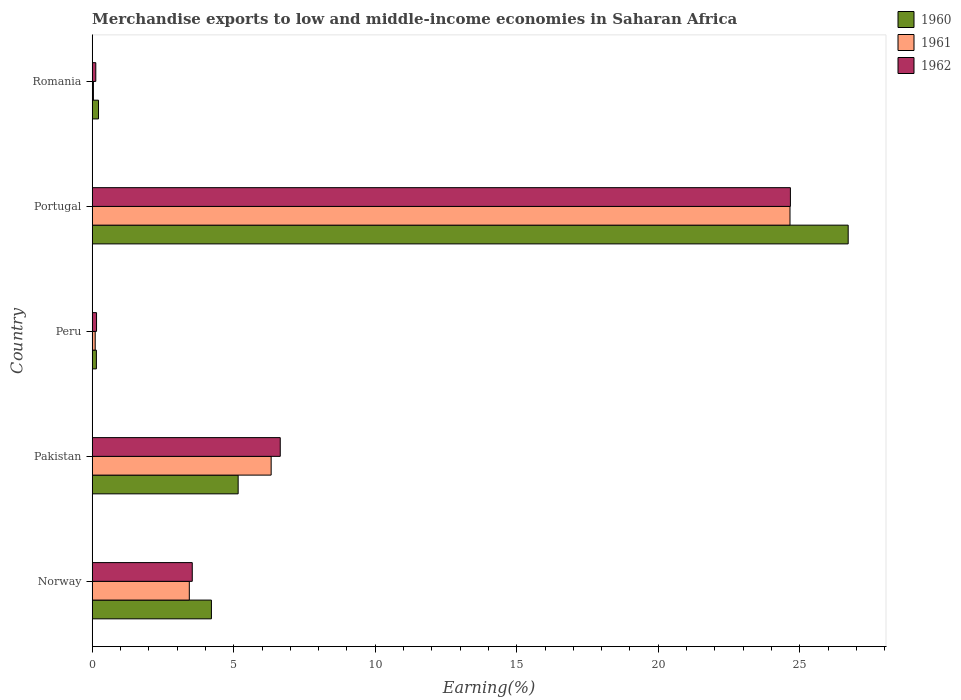How many different coloured bars are there?
Ensure brevity in your answer.  3. How many bars are there on the 3rd tick from the top?
Give a very brief answer. 3. How many bars are there on the 1st tick from the bottom?
Offer a very short reply. 3. What is the label of the 3rd group of bars from the top?
Provide a succinct answer. Peru. In how many cases, is the number of bars for a given country not equal to the number of legend labels?
Offer a terse response. 0. What is the percentage of amount earned from merchandise exports in 1960 in Portugal?
Provide a short and direct response. 26.71. Across all countries, what is the maximum percentage of amount earned from merchandise exports in 1960?
Keep it short and to the point. 26.71. Across all countries, what is the minimum percentage of amount earned from merchandise exports in 1960?
Offer a terse response. 0.15. In which country was the percentage of amount earned from merchandise exports in 1962 maximum?
Ensure brevity in your answer.  Portugal. In which country was the percentage of amount earned from merchandise exports in 1961 minimum?
Your answer should be very brief. Romania. What is the total percentage of amount earned from merchandise exports in 1961 in the graph?
Offer a terse response. 34.55. What is the difference between the percentage of amount earned from merchandise exports in 1960 in Peru and that in Romania?
Your response must be concise. -0.07. What is the difference between the percentage of amount earned from merchandise exports in 1961 in Peru and the percentage of amount earned from merchandise exports in 1960 in Portugal?
Your answer should be very brief. -26.6. What is the average percentage of amount earned from merchandise exports in 1961 per country?
Ensure brevity in your answer.  6.91. What is the difference between the percentage of amount earned from merchandise exports in 1961 and percentage of amount earned from merchandise exports in 1960 in Pakistan?
Your answer should be compact. 1.17. In how many countries, is the percentage of amount earned from merchandise exports in 1960 greater than 1 %?
Provide a succinct answer. 3. What is the ratio of the percentage of amount earned from merchandise exports in 1960 in Peru to that in Portugal?
Your answer should be compact. 0.01. Is the percentage of amount earned from merchandise exports in 1962 in Pakistan less than that in Romania?
Your response must be concise. No. Is the difference between the percentage of amount earned from merchandise exports in 1961 in Pakistan and Peru greater than the difference between the percentage of amount earned from merchandise exports in 1960 in Pakistan and Peru?
Your answer should be very brief. Yes. What is the difference between the highest and the second highest percentage of amount earned from merchandise exports in 1960?
Provide a short and direct response. 21.55. What is the difference between the highest and the lowest percentage of amount earned from merchandise exports in 1960?
Your answer should be compact. 26.56. Is the sum of the percentage of amount earned from merchandise exports in 1961 in Pakistan and Romania greater than the maximum percentage of amount earned from merchandise exports in 1962 across all countries?
Your answer should be compact. No. What does the 2nd bar from the bottom in Portugal represents?
Provide a succinct answer. 1961. What is the difference between two consecutive major ticks on the X-axis?
Make the answer very short. 5. Does the graph contain any zero values?
Offer a very short reply. No. Where does the legend appear in the graph?
Your response must be concise. Top right. What is the title of the graph?
Your answer should be very brief. Merchandise exports to low and middle-income economies in Saharan Africa. What is the label or title of the X-axis?
Offer a terse response. Earning(%). What is the Earning(%) of 1960 in Norway?
Provide a succinct answer. 4.21. What is the Earning(%) of 1961 in Norway?
Make the answer very short. 3.43. What is the Earning(%) of 1962 in Norway?
Your answer should be very brief. 3.53. What is the Earning(%) in 1960 in Pakistan?
Offer a terse response. 5.16. What is the Earning(%) of 1961 in Pakistan?
Provide a short and direct response. 6.32. What is the Earning(%) of 1962 in Pakistan?
Your answer should be compact. 6.64. What is the Earning(%) in 1960 in Peru?
Your answer should be very brief. 0.15. What is the Earning(%) in 1961 in Peru?
Provide a short and direct response. 0.1. What is the Earning(%) of 1962 in Peru?
Provide a short and direct response. 0.15. What is the Earning(%) in 1960 in Portugal?
Keep it short and to the point. 26.71. What is the Earning(%) of 1961 in Portugal?
Your response must be concise. 24.65. What is the Earning(%) of 1962 in Portugal?
Provide a succinct answer. 24.67. What is the Earning(%) of 1960 in Romania?
Your answer should be very brief. 0.22. What is the Earning(%) in 1961 in Romania?
Provide a succinct answer. 0.04. What is the Earning(%) of 1962 in Romania?
Make the answer very short. 0.13. Across all countries, what is the maximum Earning(%) of 1960?
Your answer should be compact. 26.71. Across all countries, what is the maximum Earning(%) in 1961?
Offer a terse response. 24.65. Across all countries, what is the maximum Earning(%) of 1962?
Provide a short and direct response. 24.67. Across all countries, what is the minimum Earning(%) of 1960?
Give a very brief answer. 0.15. Across all countries, what is the minimum Earning(%) of 1961?
Give a very brief answer. 0.04. Across all countries, what is the minimum Earning(%) in 1962?
Provide a succinct answer. 0.13. What is the total Earning(%) in 1960 in the graph?
Your response must be concise. 36.45. What is the total Earning(%) in 1961 in the graph?
Offer a terse response. 34.55. What is the total Earning(%) of 1962 in the graph?
Make the answer very short. 35.12. What is the difference between the Earning(%) in 1960 in Norway and that in Pakistan?
Your response must be concise. -0.94. What is the difference between the Earning(%) of 1961 in Norway and that in Pakistan?
Your answer should be very brief. -2.89. What is the difference between the Earning(%) in 1962 in Norway and that in Pakistan?
Provide a succinct answer. -3.11. What is the difference between the Earning(%) of 1960 in Norway and that in Peru?
Offer a terse response. 4.06. What is the difference between the Earning(%) in 1961 in Norway and that in Peru?
Your response must be concise. 3.32. What is the difference between the Earning(%) of 1962 in Norway and that in Peru?
Provide a succinct answer. 3.38. What is the difference between the Earning(%) in 1960 in Norway and that in Portugal?
Make the answer very short. -22.5. What is the difference between the Earning(%) in 1961 in Norway and that in Portugal?
Your answer should be very brief. -21.22. What is the difference between the Earning(%) in 1962 in Norway and that in Portugal?
Ensure brevity in your answer.  -21.13. What is the difference between the Earning(%) in 1960 in Norway and that in Romania?
Your response must be concise. 3.99. What is the difference between the Earning(%) in 1961 in Norway and that in Romania?
Offer a very short reply. 3.39. What is the difference between the Earning(%) in 1962 in Norway and that in Romania?
Your response must be concise. 3.41. What is the difference between the Earning(%) in 1960 in Pakistan and that in Peru?
Make the answer very short. 5.01. What is the difference between the Earning(%) of 1961 in Pakistan and that in Peru?
Make the answer very short. 6.22. What is the difference between the Earning(%) in 1962 in Pakistan and that in Peru?
Your response must be concise. 6.49. What is the difference between the Earning(%) in 1960 in Pakistan and that in Portugal?
Give a very brief answer. -21.55. What is the difference between the Earning(%) in 1961 in Pakistan and that in Portugal?
Offer a very short reply. -18.33. What is the difference between the Earning(%) of 1962 in Pakistan and that in Portugal?
Your answer should be compact. -18.03. What is the difference between the Earning(%) of 1960 in Pakistan and that in Romania?
Provide a short and direct response. 4.93. What is the difference between the Earning(%) of 1961 in Pakistan and that in Romania?
Provide a short and direct response. 6.28. What is the difference between the Earning(%) of 1962 in Pakistan and that in Romania?
Make the answer very short. 6.52. What is the difference between the Earning(%) in 1960 in Peru and that in Portugal?
Your answer should be compact. -26.56. What is the difference between the Earning(%) in 1961 in Peru and that in Portugal?
Offer a terse response. -24.55. What is the difference between the Earning(%) of 1962 in Peru and that in Portugal?
Give a very brief answer. -24.52. What is the difference between the Earning(%) in 1960 in Peru and that in Romania?
Give a very brief answer. -0.07. What is the difference between the Earning(%) of 1961 in Peru and that in Romania?
Keep it short and to the point. 0.06. What is the difference between the Earning(%) of 1962 in Peru and that in Romania?
Give a very brief answer. 0.03. What is the difference between the Earning(%) of 1960 in Portugal and that in Romania?
Keep it short and to the point. 26.49. What is the difference between the Earning(%) of 1961 in Portugal and that in Romania?
Ensure brevity in your answer.  24.61. What is the difference between the Earning(%) in 1962 in Portugal and that in Romania?
Provide a short and direct response. 24.54. What is the difference between the Earning(%) of 1960 in Norway and the Earning(%) of 1961 in Pakistan?
Offer a terse response. -2.11. What is the difference between the Earning(%) of 1960 in Norway and the Earning(%) of 1962 in Pakistan?
Your response must be concise. -2.43. What is the difference between the Earning(%) of 1961 in Norway and the Earning(%) of 1962 in Pakistan?
Your answer should be compact. -3.21. What is the difference between the Earning(%) in 1960 in Norway and the Earning(%) in 1961 in Peru?
Provide a short and direct response. 4.11. What is the difference between the Earning(%) of 1960 in Norway and the Earning(%) of 1962 in Peru?
Keep it short and to the point. 4.06. What is the difference between the Earning(%) of 1961 in Norway and the Earning(%) of 1962 in Peru?
Your response must be concise. 3.28. What is the difference between the Earning(%) of 1960 in Norway and the Earning(%) of 1961 in Portugal?
Your answer should be very brief. -20.44. What is the difference between the Earning(%) of 1960 in Norway and the Earning(%) of 1962 in Portugal?
Your response must be concise. -20.46. What is the difference between the Earning(%) of 1961 in Norway and the Earning(%) of 1962 in Portugal?
Your response must be concise. -21.24. What is the difference between the Earning(%) in 1960 in Norway and the Earning(%) in 1961 in Romania?
Offer a terse response. 4.17. What is the difference between the Earning(%) in 1960 in Norway and the Earning(%) in 1962 in Romania?
Give a very brief answer. 4.09. What is the difference between the Earning(%) in 1961 in Norway and the Earning(%) in 1962 in Romania?
Offer a very short reply. 3.3. What is the difference between the Earning(%) in 1960 in Pakistan and the Earning(%) in 1961 in Peru?
Your answer should be very brief. 5.05. What is the difference between the Earning(%) of 1960 in Pakistan and the Earning(%) of 1962 in Peru?
Your answer should be compact. 5. What is the difference between the Earning(%) of 1961 in Pakistan and the Earning(%) of 1962 in Peru?
Provide a short and direct response. 6.17. What is the difference between the Earning(%) in 1960 in Pakistan and the Earning(%) in 1961 in Portugal?
Provide a succinct answer. -19.5. What is the difference between the Earning(%) in 1960 in Pakistan and the Earning(%) in 1962 in Portugal?
Offer a terse response. -19.51. What is the difference between the Earning(%) in 1961 in Pakistan and the Earning(%) in 1962 in Portugal?
Give a very brief answer. -18.35. What is the difference between the Earning(%) of 1960 in Pakistan and the Earning(%) of 1961 in Romania?
Keep it short and to the point. 5.11. What is the difference between the Earning(%) of 1960 in Pakistan and the Earning(%) of 1962 in Romania?
Give a very brief answer. 5.03. What is the difference between the Earning(%) of 1961 in Pakistan and the Earning(%) of 1962 in Romania?
Your response must be concise. 6.2. What is the difference between the Earning(%) of 1960 in Peru and the Earning(%) of 1961 in Portugal?
Keep it short and to the point. -24.51. What is the difference between the Earning(%) of 1960 in Peru and the Earning(%) of 1962 in Portugal?
Your answer should be compact. -24.52. What is the difference between the Earning(%) of 1961 in Peru and the Earning(%) of 1962 in Portugal?
Your response must be concise. -24.56. What is the difference between the Earning(%) of 1960 in Peru and the Earning(%) of 1961 in Romania?
Offer a very short reply. 0.1. What is the difference between the Earning(%) in 1960 in Peru and the Earning(%) in 1962 in Romania?
Provide a succinct answer. 0.02. What is the difference between the Earning(%) of 1961 in Peru and the Earning(%) of 1962 in Romania?
Offer a terse response. -0.02. What is the difference between the Earning(%) in 1960 in Portugal and the Earning(%) in 1961 in Romania?
Your answer should be very brief. 26.67. What is the difference between the Earning(%) of 1960 in Portugal and the Earning(%) of 1962 in Romania?
Provide a succinct answer. 26.58. What is the difference between the Earning(%) in 1961 in Portugal and the Earning(%) in 1962 in Romania?
Make the answer very short. 24.53. What is the average Earning(%) of 1960 per country?
Your answer should be very brief. 7.29. What is the average Earning(%) in 1961 per country?
Offer a terse response. 6.91. What is the average Earning(%) of 1962 per country?
Keep it short and to the point. 7.02. What is the difference between the Earning(%) of 1960 and Earning(%) of 1961 in Norway?
Keep it short and to the point. 0.78. What is the difference between the Earning(%) of 1960 and Earning(%) of 1962 in Norway?
Ensure brevity in your answer.  0.68. What is the difference between the Earning(%) of 1961 and Earning(%) of 1962 in Norway?
Your answer should be compact. -0.1. What is the difference between the Earning(%) of 1960 and Earning(%) of 1961 in Pakistan?
Provide a succinct answer. -1.17. What is the difference between the Earning(%) of 1960 and Earning(%) of 1962 in Pakistan?
Your answer should be compact. -1.49. What is the difference between the Earning(%) in 1961 and Earning(%) in 1962 in Pakistan?
Offer a terse response. -0.32. What is the difference between the Earning(%) of 1960 and Earning(%) of 1961 in Peru?
Ensure brevity in your answer.  0.04. What is the difference between the Earning(%) in 1960 and Earning(%) in 1962 in Peru?
Your answer should be compact. -0.01. What is the difference between the Earning(%) of 1961 and Earning(%) of 1962 in Peru?
Provide a succinct answer. -0.05. What is the difference between the Earning(%) of 1960 and Earning(%) of 1961 in Portugal?
Your answer should be very brief. 2.06. What is the difference between the Earning(%) in 1960 and Earning(%) in 1962 in Portugal?
Your response must be concise. 2.04. What is the difference between the Earning(%) in 1961 and Earning(%) in 1962 in Portugal?
Give a very brief answer. -0.01. What is the difference between the Earning(%) in 1960 and Earning(%) in 1961 in Romania?
Your response must be concise. 0.18. What is the difference between the Earning(%) in 1960 and Earning(%) in 1962 in Romania?
Offer a terse response. 0.1. What is the difference between the Earning(%) of 1961 and Earning(%) of 1962 in Romania?
Make the answer very short. -0.08. What is the ratio of the Earning(%) in 1960 in Norway to that in Pakistan?
Your answer should be compact. 0.82. What is the ratio of the Earning(%) in 1961 in Norway to that in Pakistan?
Provide a short and direct response. 0.54. What is the ratio of the Earning(%) in 1962 in Norway to that in Pakistan?
Your answer should be compact. 0.53. What is the ratio of the Earning(%) in 1960 in Norway to that in Peru?
Your answer should be compact. 28.69. What is the ratio of the Earning(%) of 1961 in Norway to that in Peru?
Give a very brief answer. 32.67. What is the ratio of the Earning(%) of 1962 in Norway to that in Peru?
Ensure brevity in your answer.  23.23. What is the ratio of the Earning(%) in 1960 in Norway to that in Portugal?
Your answer should be very brief. 0.16. What is the ratio of the Earning(%) of 1961 in Norway to that in Portugal?
Offer a very short reply. 0.14. What is the ratio of the Earning(%) of 1962 in Norway to that in Portugal?
Your answer should be compact. 0.14. What is the ratio of the Earning(%) of 1960 in Norway to that in Romania?
Provide a short and direct response. 19. What is the ratio of the Earning(%) in 1961 in Norway to that in Romania?
Provide a succinct answer. 81.93. What is the ratio of the Earning(%) in 1962 in Norway to that in Romania?
Your response must be concise. 28.18. What is the ratio of the Earning(%) of 1960 in Pakistan to that in Peru?
Keep it short and to the point. 35.13. What is the ratio of the Earning(%) of 1961 in Pakistan to that in Peru?
Your answer should be very brief. 60.22. What is the ratio of the Earning(%) of 1962 in Pakistan to that in Peru?
Give a very brief answer. 43.66. What is the ratio of the Earning(%) in 1960 in Pakistan to that in Portugal?
Offer a terse response. 0.19. What is the ratio of the Earning(%) in 1961 in Pakistan to that in Portugal?
Keep it short and to the point. 0.26. What is the ratio of the Earning(%) of 1962 in Pakistan to that in Portugal?
Make the answer very short. 0.27. What is the ratio of the Earning(%) in 1960 in Pakistan to that in Romania?
Provide a succinct answer. 23.26. What is the ratio of the Earning(%) of 1961 in Pakistan to that in Romania?
Provide a short and direct response. 151. What is the ratio of the Earning(%) of 1962 in Pakistan to that in Romania?
Make the answer very short. 52.96. What is the ratio of the Earning(%) in 1960 in Peru to that in Portugal?
Your answer should be very brief. 0.01. What is the ratio of the Earning(%) of 1961 in Peru to that in Portugal?
Offer a terse response. 0. What is the ratio of the Earning(%) of 1962 in Peru to that in Portugal?
Offer a terse response. 0.01. What is the ratio of the Earning(%) in 1960 in Peru to that in Romania?
Provide a succinct answer. 0.66. What is the ratio of the Earning(%) of 1961 in Peru to that in Romania?
Give a very brief answer. 2.51. What is the ratio of the Earning(%) of 1962 in Peru to that in Romania?
Make the answer very short. 1.21. What is the ratio of the Earning(%) of 1960 in Portugal to that in Romania?
Offer a terse response. 120.48. What is the ratio of the Earning(%) of 1961 in Portugal to that in Romania?
Provide a short and direct response. 588.91. What is the ratio of the Earning(%) in 1962 in Portugal to that in Romania?
Your response must be concise. 196.67. What is the difference between the highest and the second highest Earning(%) in 1960?
Provide a succinct answer. 21.55. What is the difference between the highest and the second highest Earning(%) of 1961?
Give a very brief answer. 18.33. What is the difference between the highest and the second highest Earning(%) in 1962?
Your answer should be very brief. 18.03. What is the difference between the highest and the lowest Earning(%) in 1960?
Provide a short and direct response. 26.56. What is the difference between the highest and the lowest Earning(%) of 1961?
Make the answer very short. 24.61. What is the difference between the highest and the lowest Earning(%) in 1962?
Your answer should be compact. 24.54. 